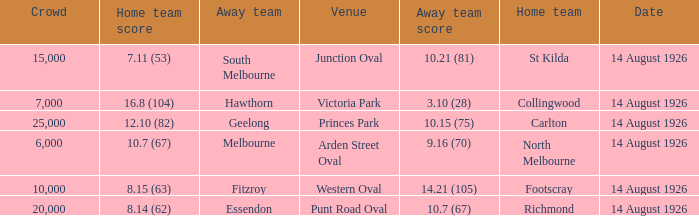What was the crowd size at Victoria Park? 7000.0. 